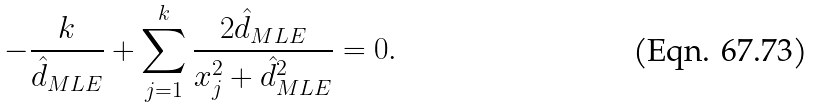Convert formula to latex. <formula><loc_0><loc_0><loc_500><loc_500>- \frac { k } { \hat { d } _ { M L E } } + \sum _ { j = 1 } ^ { k } \frac { 2 \hat { d } _ { M L E } } { x _ { j } ^ { 2 } + \hat { d } _ { M L E } ^ { 2 } } = 0 .</formula> 